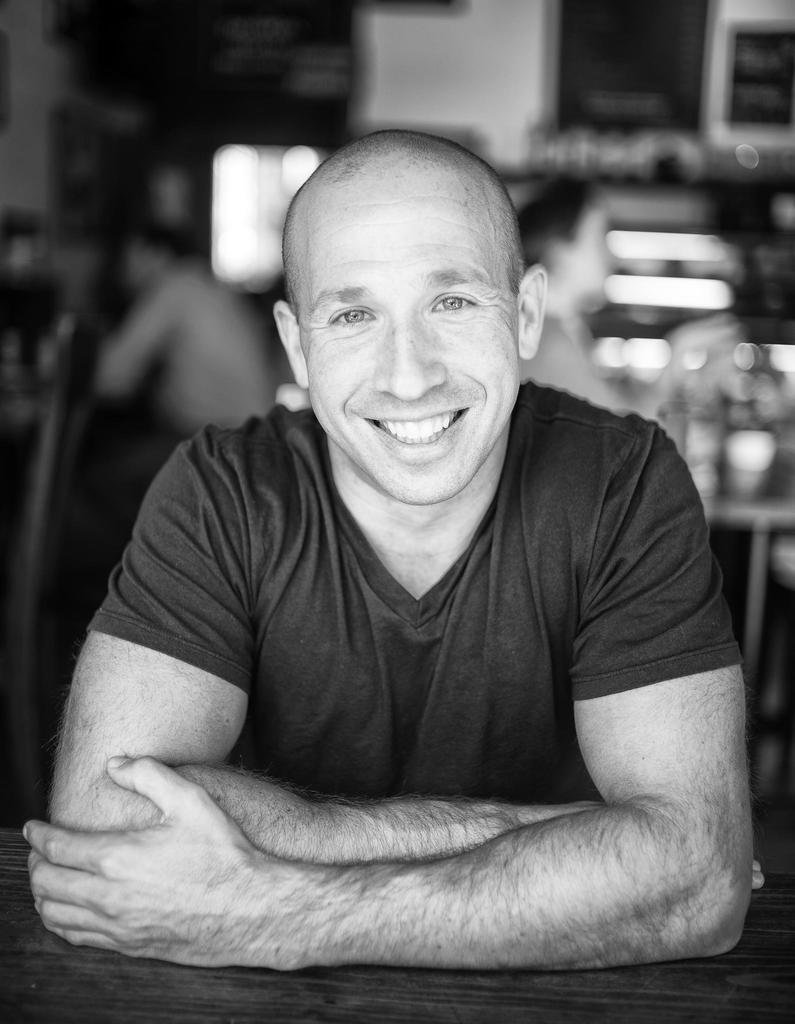In one or two sentences, can you explain what this image depicts? This is a black and white picture, in this image we can see a person smiling and the background is blurred. 